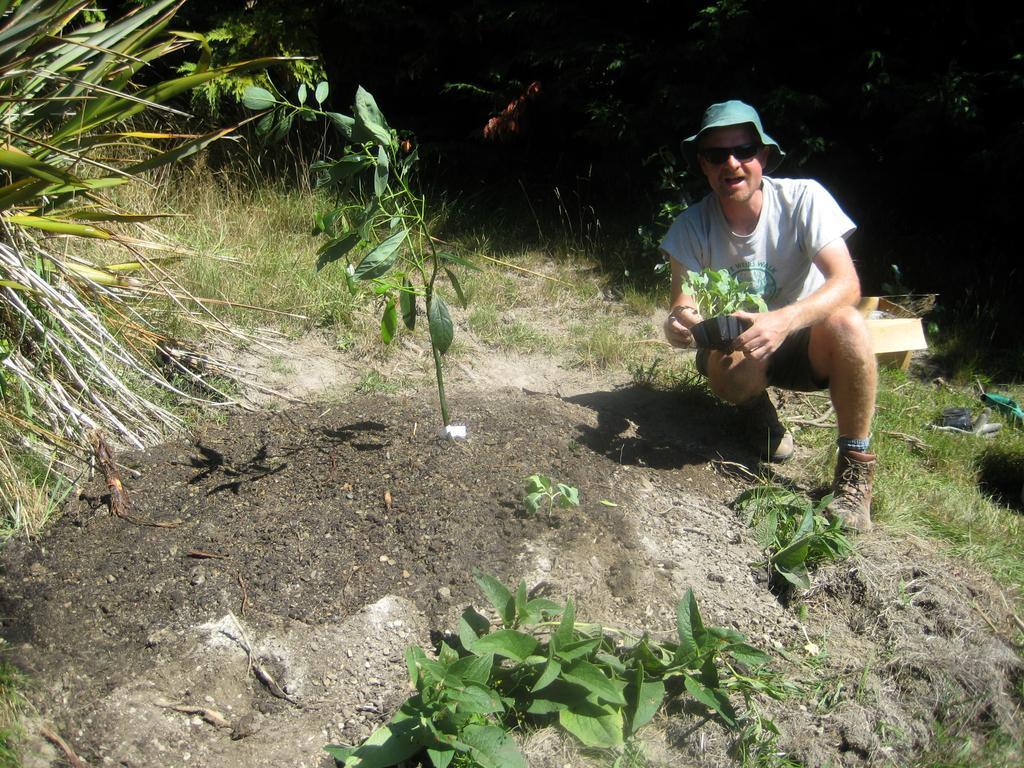Could you give a brief overview of what you see in this image? In this image we can see a person wearing a hat holding a plant with a pot. We can also see some grass and the plants. 